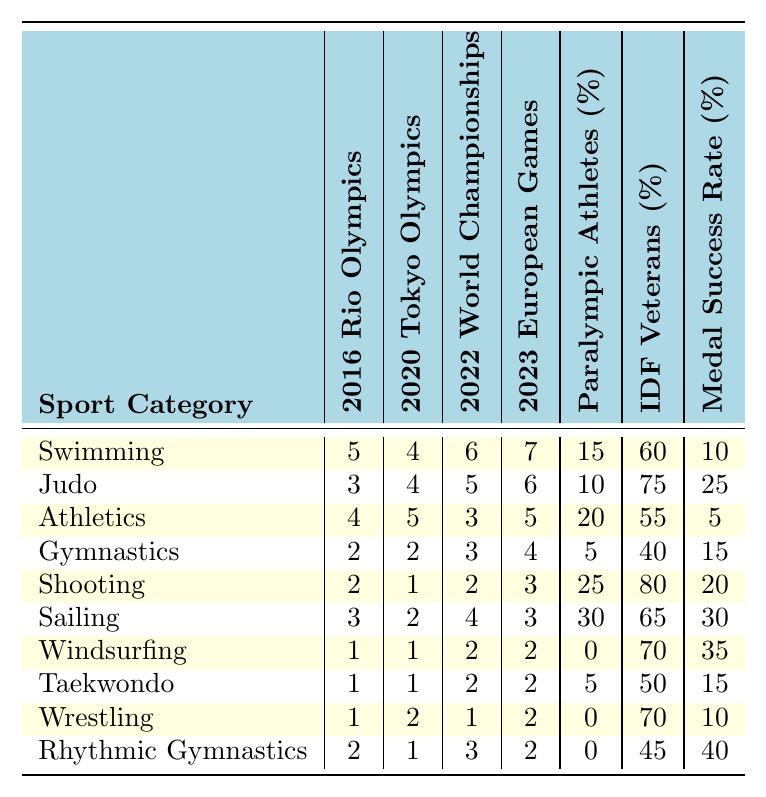What sport category had the highest participation in the 2023 European Games? The table shows that Swimming had the highest participation with 7 athletes in the 2023 European Games.
Answer: Swimming How many athletes represented Athletics in the 2016 Rio Olympics? The table indicates that 4 athletes represented the Athletics category in the 2016 Rio Olympics.
Answer: 4 Which sport has the lowest percentage of Paralympic athletes? The data shows that Windsurfing had 0% of Paralympic athletes, which is the lowest percentage listed.
Answer: Windsurfing What sport category experienced a decrease in participation from the 2016 Rio Olympics to the 2020 Tokyo Olympics? The participation numbers for Shooting decreased from 2 in 2016 to 1 in 2020, indicating a decline.
Answer: Shooting Which sport category has the highest IDF Veterans percentage? The table shows that Shooting has the highest IDF Veterans percentage at 80%.
Answer: Shooting What is the average medal success rate for all sports listed? To find the average, sum the medal success rates: (10 + 25 + 5 + 15 + 20 + 30 + 35 + 15 + 10 + 40) = 205. There are 10 categories, so the average is 205 / 10 = 20.5%.
Answer: 20.5 Did Judo have more participants in the 2022 World Championships compared to the 2020 Tokyo Olympics? Yes, Judo had 5 participants in the 2022 World Championships and 4 in the 2020 Tokyo Olympics, showing an increase.
Answer: Yes What is the difference in participation between the 2022 World Championships and the 2023 European Games for Rhythmic Gymnastics? Rhythmic Gymnastics participated with 3 athletes in the 2022 World Championships and 2 in the 2023 European Games. The difference is 3 - 2 = 1.
Answer: 1 Which sport category had the same participation in both the 2020 Tokyo Olympics and 2023 European Games? The table indicates that Taekwondo had the same participation of 1 athlete in both the 2020 Tokyo Olympics and the 2023 European Games.
Answer: Taekwondo How many more athletes participated in Swimming at the 2023 European Games compared to Judo in the same event? Swimming had 7 athletes while Judo had 6 athletes in the 2023 European Games. The difference is 7 - 6 = 1.
Answer: 1 